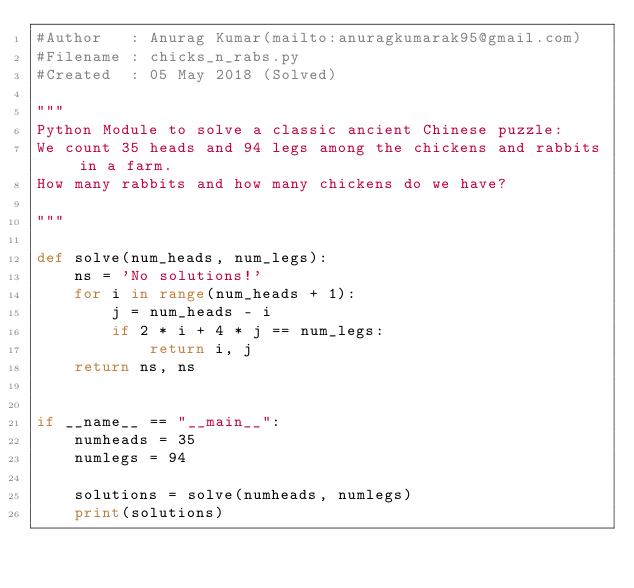Convert code to text. <code><loc_0><loc_0><loc_500><loc_500><_Python_>#Author   : Anurag Kumar(mailto:anuragkumarak95@gmail.com)
#Filename : chicks_n_rabs.py
#Created  : 05 May 2018 (Solved)

"""
Python Module to solve a classic ancient Chinese puzzle:
We count 35 heads and 94 legs among the chickens and rabbits in a farm. 
How many rabbits and how many chickens do we have?

"""

def solve(num_heads, num_legs):
    ns = 'No solutions!'
    for i in range(num_heads + 1):
        j = num_heads - i
        if 2 * i + 4 * j == num_legs:
            return i, j
    return ns, ns


if __name__ == "__main__":
    numheads = 35
    numlegs = 94

    solutions = solve(numheads, numlegs)
    print(solutions)
</code> 